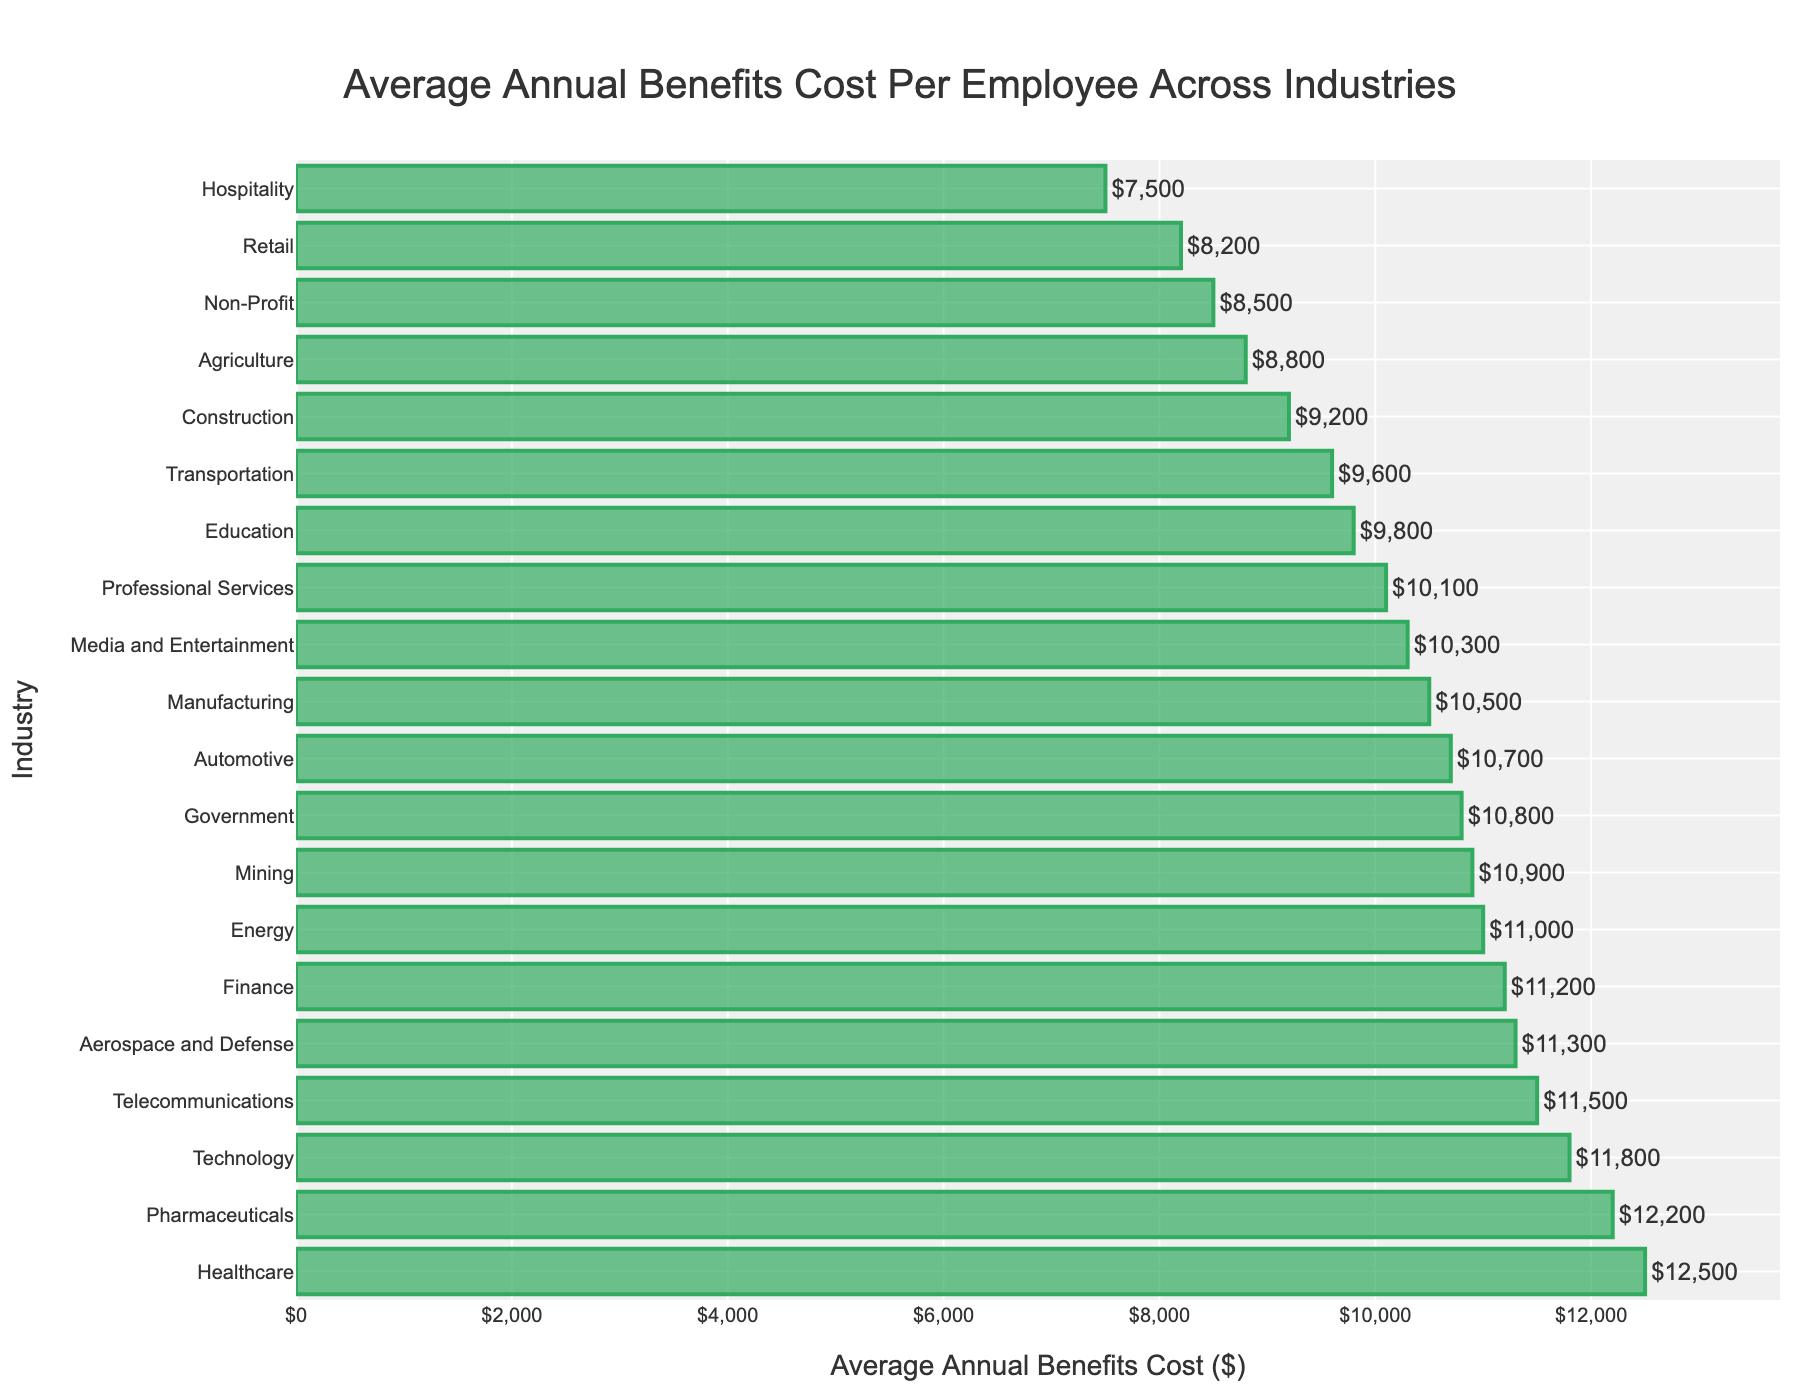What industry has the highest average annual benefits cost per employee? By examining the bar chart, we can see that the longest bar corresponds to the industry with the highest benefits cost. The Healthcare industry has the longest bar, indicating the highest cost.
Answer: Healthcare Which industry has the lowest average annual benefits cost per employee? The shortest bar in the bar chart represents the industry with the lowest benefits cost. The Hospitality industry has the shortest bar.
Answer: Hospitality What is the difference in average annual benefits cost per employee between the Healthcare and Technology industries? From the bar chart, Healthcare has a benefits cost of $12,500 and Technology has $11,800. Subtracting these values gives the difference: $12,500 - $11,800 = $700.
Answer: $700 How many industries have an average annual benefits cost per employee of more than $10,000? By counting the bars whose values exceed $10,000 in the chart, we identify these industries: Healthcare, Technology, Pharmaceuticals, Telecommunications, Aerospace and Defense, Finance, Energy, Mining, and Government, totaling 9 industries.
Answer: 9 Which industries have an average annual benefits cost per employee that falls between $9,000 and $10,000? From the chart, the bars representing the industries with costs in this range are Construction, Transportation, and Education. These bars fall between $9,000 and $10,000.
Answer: Construction, Transportation, Education What is the median average annual benefits cost per employee across all industries? Sorting the benefits costs in ascending order: $7,500, $8,200, $8,500, $8,800, $9,200, $9,600, $9,800, $10,100, $10,300, $10,500, $10,700, $10,800, $11,000, $11,200, $11,300, $11,500, $11,800, $12,200, $12,500. With 19 data points, the median is the 10th value, which is $10,500.
Answer: $10,500 Compare the average annual benefits costs per employee between Aerospace and Defense and Pharmaceutical industries. Which one is higher and by how much? From the chart, Aerospace and Defense has a cost of $11,300 and Pharmaceuticals has $12,200. The difference is $12,200 - $11,300 = $900, with Pharmaceuticals being higher.
Answer: Pharmaceuticals by $900 What is the total average annual benefits cost of the three industries with the highest values? The three industries with the highest values are Healthcare ($12,500), Pharmaceuticals ($12,200), and Technology ($11,800). Summing these gives: $12,500 + $12,200 + $11,800 = $36,500.
Answer: $36,500 Between Retail and Media and Entertainment industries, which has a higher average annual benefits cost per employee, and what is the percentage increase from Retail to Media and Entertainment? Retail has an average benefits cost of $8,200, while Media and Entertainment has $10,300. The increase is $10,300 - $8,200 = $2,100. To find the percentage increase: ($2,100 / $8,200) * 100 ≈ 25.61%.
Answer: Media and Entertainment with a ~25.61% increase 